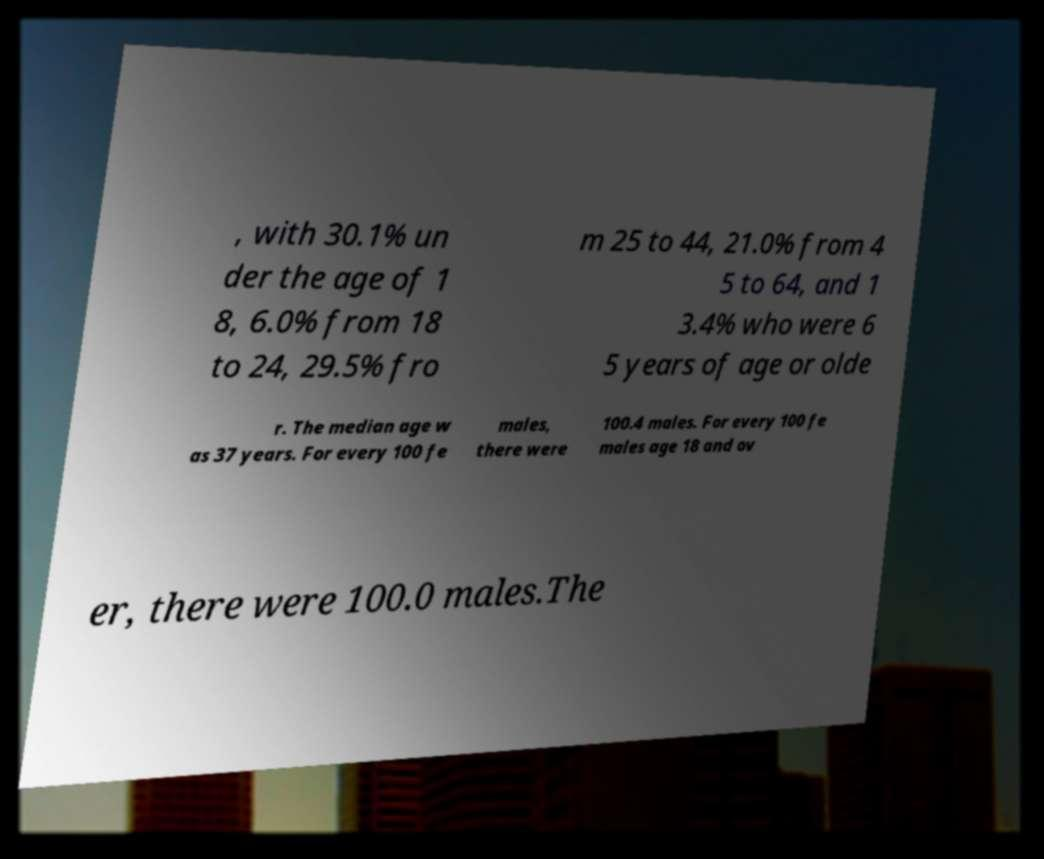Please identify and transcribe the text found in this image. , with 30.1% un der the age of 1 8, 6.0% from 18 to 24, 29.5% fro m 25 to 44, 21.0% from 4 5 to 64, and 1 3.4% who were 6 5 years of age or olde r. The median age w as 37 years. For every 100 fe males, there were 100.4 males. For every 100 fe males age 18 and ov er, there were 100.0 males.The 